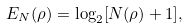Convert formula to latex. <formula><loc_0><loc_0><loc_500><loc_500>E _ { N } ( \rho ) = \log _ { 2 } [ { N } ( { \rho } ) + 1 ] ,</formula> 